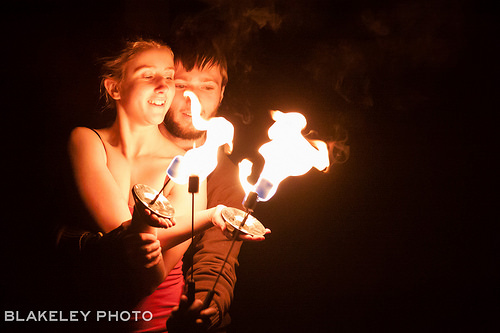<image>
Is the fire on the girl? No. The fire is not positioned on the girl. They may be near each other, but the fire is not supported by or resting on top of the girl. 